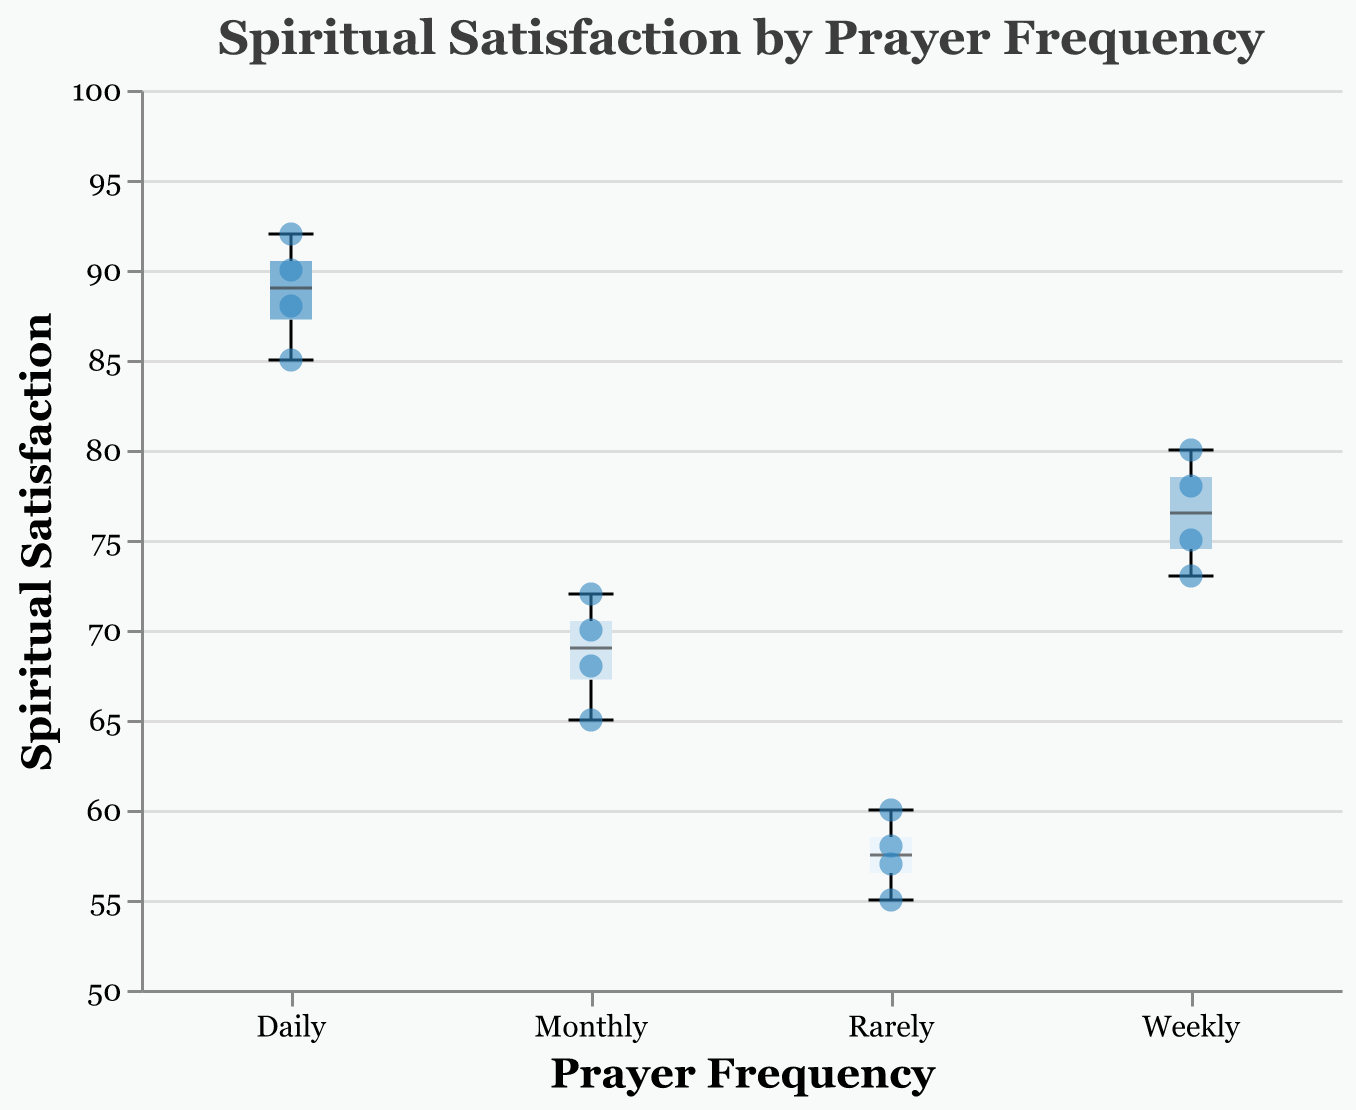What's the title of the figure? The title is displayed at the top of the figure. It reads, "Spiritual Satisfaction by Prayer Frequency".
Answer: Spiritual Satisfaction by Prayer Frequency What is the highest recorded Spiritual Satisfaction score with daily prayer frequency? Looking at the scatter points in the Daily prayer frequency category, the highest point on the y-axis is 92.
Answer: 92 Which prayer frequency group has the lowest median Spiritual Satisfaction score? The boxplot median line represents the median value. The Rarely group shows the lowest median among all groups.
Answer: Rarely Compare the upper whiskers of the Weekly and Monthly prayer frequency groups. Which one is higher? The top whisker of the Weekly group is at a higher Spiritual Satisfaction score compared to the Monthly group. Weekly's upper whisker extends to 80, while Monthly reaches about 72.
Answer: Weekly How many individual data points are represented for the Rarely prayer frequency group? By counting the scatter points within the Rarely group, there are 4 data points.
Answer: 4 What's the median Spiritual Satisfaction score for the Daily prayer frequency group? The median is the middle line within the box of the boxplot. The Daily group's median line is at 88.
Answer: 88 What range does the box for the Weekly prayer frequency group cover? The box for Weekly spans from about 73 to 80 on the Spiritual Satisfaction axis.
Answer: 73 to 80 Which prayer frequency group shows the highest variability in Spiritual Satisfaction scores? Variability is indicated by the range between the minimum and maximum values. The Daily group has a smaller range while the Rarely group has a larger range. Thus, Rarely shows the highest variability.
Answer: Rarely Is there an overlap in Spiritual Satisfaction scores between the Monthly and Weekly prayer frequency groups? Observing the box plots for these groups, both cover a range of 68-80 (Monthly) and 73-80 (Weekly), showing that there is an overlap in scores from 73 to 72.
Answer: Yes 